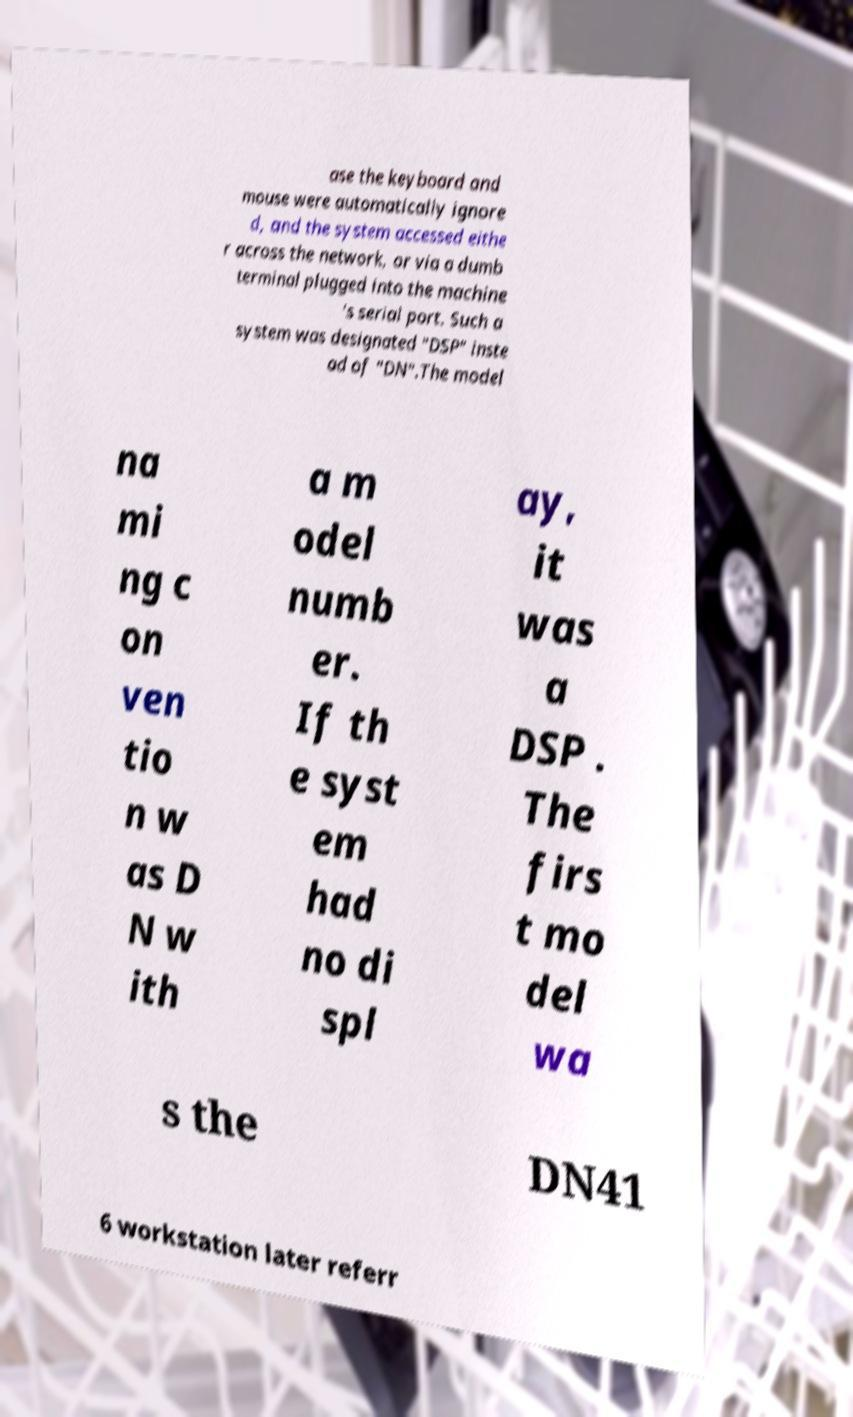Can you accurately transcribe the text from the provided image for me? ase the keyboard and mouse were automatically ignore d, and the system accessed eithe r across the network, or via a dumb terminal plugged into the machine 's serial port. Such a system was designated "DSP" inste ad of "DN".The model na mi ng c on ven tio n w as D N w ith a m odel numb er. If th e syst em had no di spl ay, it was a DSP . The firs t mo del wa s the DN41 6 workstation later referr 